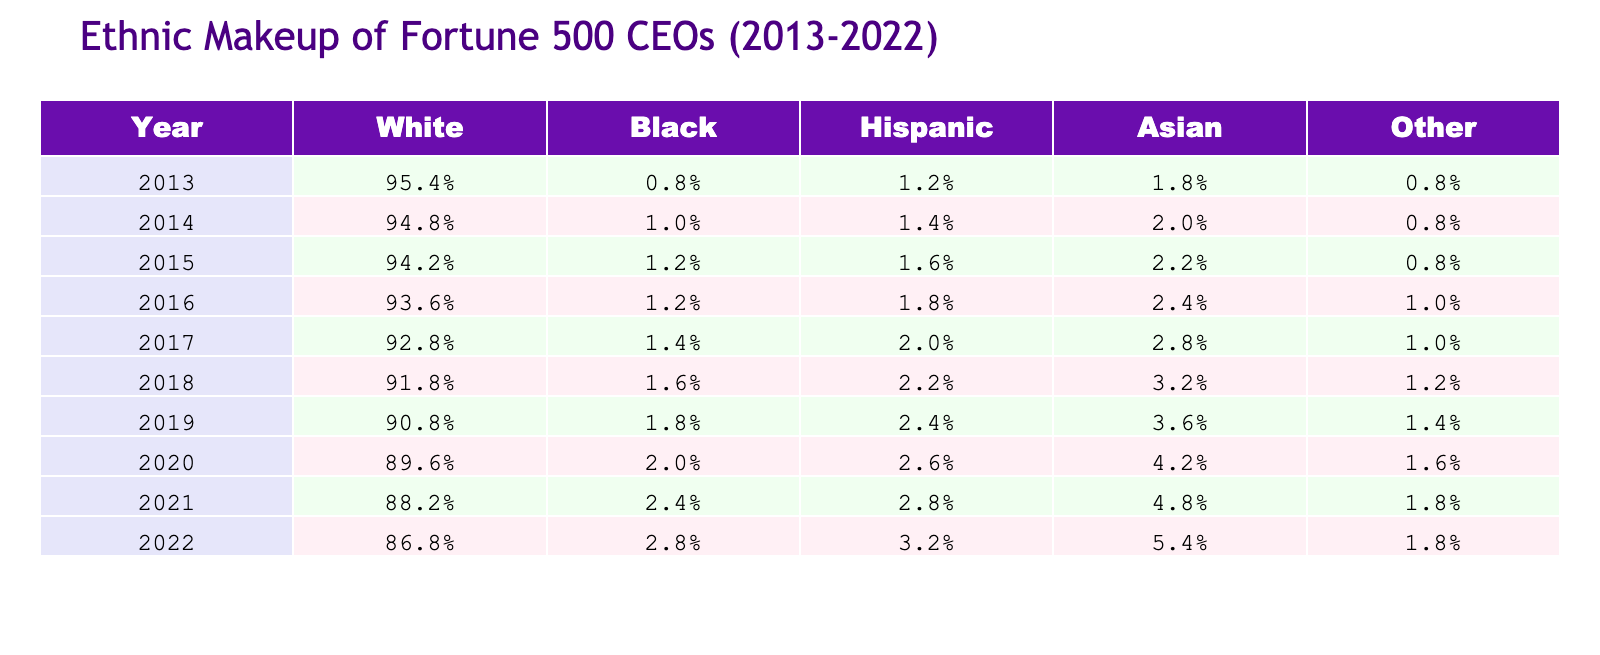What percentage of Fortune 500 CEOs were White in 2022? In the year 2022, the table shows that the percentage of White CEOs was 86.8%.
Answer: 86.8% What was the percentage increase of Asian CEOs from 2013 to 2022? Asian CEOs were 1.8% in 2013 and increased to 5.4% in 2022. The increase is calculated as (5.4% - 1.8%) = 3.6%.
Answer: 3.6% In which year was the percentage of Black CEOs the lowest? By examining the table, the lowest percentage of Black CEOs is noted in 2013 at 0.8%.
Answer: 2013 What was the average percentage of Hispanic CEOs over the years from 2013 to 2022? The percentages of Hispanic CEOs from 2013 to 2022 are 1.2%, 1.4%, 1.6%, 1.8%, 2.0%, 2.2%, 2.6%, 2.8%, and 3.2%. To find the average, we sum these percentages: (1.2 + 1.4 + 1.6 + 1.8 + 2.0 + 2.2 + 2.6 + 2.8 + 3.2) = 19.8, and then divide by the number of years, which is 9. Hence, the average is 19.8/9 = 2.2%.
Answer: 2.2% Did the percentage of Other ethnicity CEOs change positively in the last decade? Looking at the table, the percentage of Other CEOs went from 0.8% in 2013 to 1.8% in 2022. Since this is an increase, the answer is yes.
Answer: Yes What is the ratio of White to Asian CEOs in 2021? The percentage of White CEOs in 2021 is 88.2%, while for Asian CEOs it is 4.8%. To find the ratio, we calculate 88.2% / 4.8% = 18.375. This signifies that for every Asian CEO, there are about 18.4 White CEOs.
Answer: 18.375 